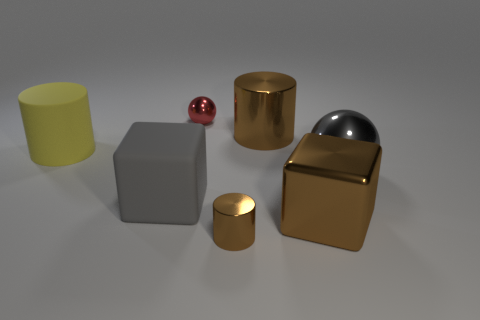Subtract all yellow rubber cylinders. How many cylinders are left? 2 Subtract all blocks. How many objects are left? 5 Add 2 big yellow rubber cylinders. How many objects exist? 9 Subtract 2 blocks. How many blocks are left? 0 Subtract all cyan balls. Subtract all red cylinders. How many balls are left? 2 Subtract all brown spheres. How many cyan cubes are left? 0 Subtract all small objects. Subtract all green metallic things. How many objects are left? 5 Add 4 brown blocks. How many brown blocks are left? 5 Add 7 large shiny balls. How many large shiny balls exist? 8 Subtract all gray blocks. How many blocks are left? 1 